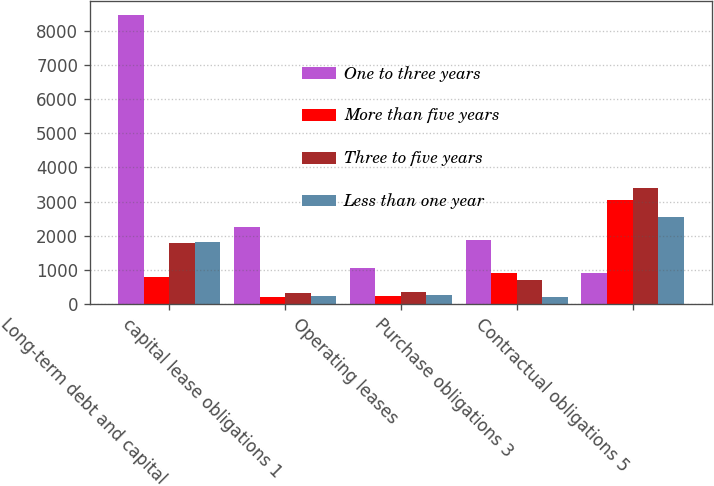Convert chart to OTSL. <chart><loc_0><loc_0><loc_500><loc_500><stacked_bar_chart><ecel><fcel>Long-term debt and capital<fcel>capital lease obligations 1<fcel>Operating leases<fcel>Purchase obligations 3<fcel>Contractual obligations 5<nl><fcel>One to three years<fcel>8469<fcel>2239<fcel>1047<fcel>1864<fcel>906<nl><fcel>More than five years<fcel>786<fcel>209<fcel>222<fcel>906<fcel>3056<nl><fcel>Three to five years<fcel>1786<fcel>328<fcel>350<fcel>709<fcel>3402<nl><fcel>Less than one year<fcel>1800<fcel>233<fcel>243<fcel>193<fcel>2543<nl></chart> 